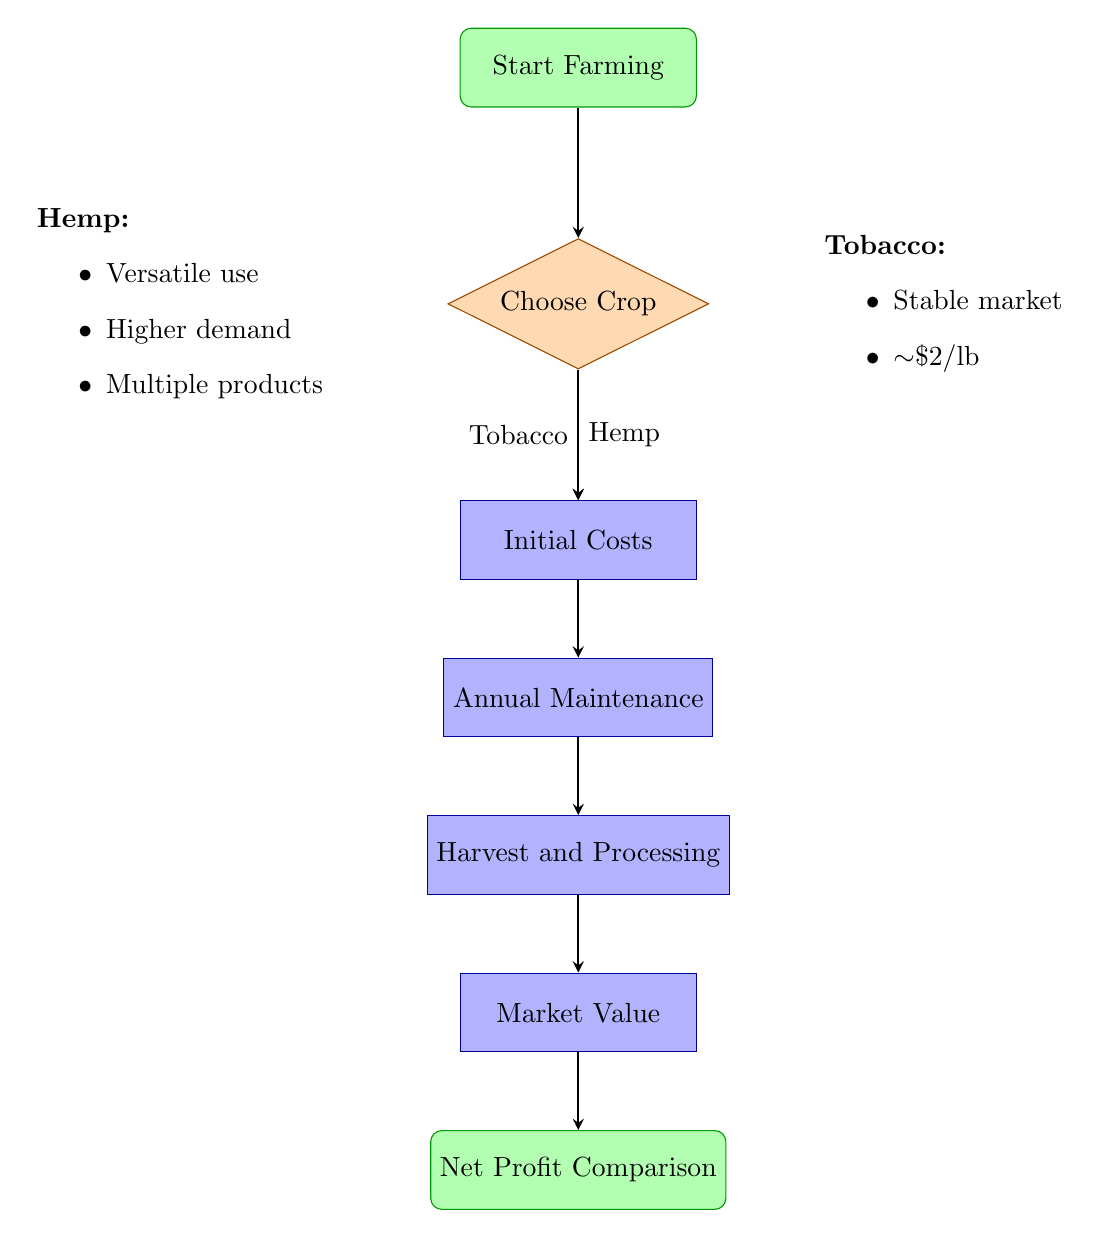What's the first step in the flow chart? The first step in the flow chart is to "Start Farming," which is the initiating action of the process.
Answer: Start Farming How many choices do I have when choosing a crop? The flow chart presents two choices at the "Choose Crop" node: Tobacco and Hemp.
Answer: Two What is one initial cost for Tobacco farming? The diagram lists three initial costs for Tobacco farming, one of which is "Seed Purchase."
Answer: Seed Purchase How does the Annual Maintenance for Hemp compare to Tobacco? The flow chart indicates that Hemp has "Pesticides (minimal)" compared to Tobacco, which generally requires a more significant amount of pesticides, showing a difference in maintenance needs.
Answer: Less What are the main products derived from Hemp after Harvest and Processing? According to the diagram, the main products derived from Hemp include "Processing (fiber, seeds, oil)."
Answer: Fiber, seeds, oil What is the market demand for Tobacco? The flow chart indicates that the market demand for Tobacco is "Stable but declining," reflecting a trend in the agricultural economy.
Answer: Stable but declining Which crop has a higher potential profit according to the flow chart? The "Net Profit Comparison" node mentions that "Hemp" has a higher potential profit due to its versatile use and rising demand compared to Tobacco.
Answer: Hemp Which step comes after Annual Maintenance? The flow chart follows a sequence where "Harvest and Processing" comes immediately after "Annual Maintenance."
Answer: Harvest and Processing What is the selling price of Tobacco per pound? According to the market value details in the diagram, Tobacco has an approximate selling price of "Approx. $2 per pound."
Answer: Approx. $2 per pound What type of maintenance does Hemp require? The diagram specifies that the maintenance for Hemp includes "Pesticides (minimal)," indicating lower maintenance needs compared to Tobacco.
Answer: Pesticides (minimal) 